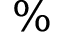Convert formula to latex. <formula><loc_0><loc_0><loc_500><loc_500>\%</formula> 